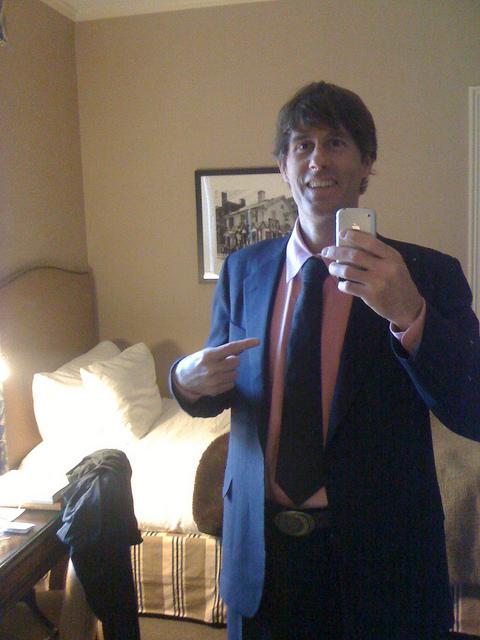Is there a box on the bed?
Answer briefly. No. What brand of phone is this?
Give a very brief answer. Apple. Is the man dressed for business or a sporting event?
Short answer required. Business. Is the bed made up?
Be succinct. Yes. Does the man have a large belt buckle?
Be succinct. Yes. 